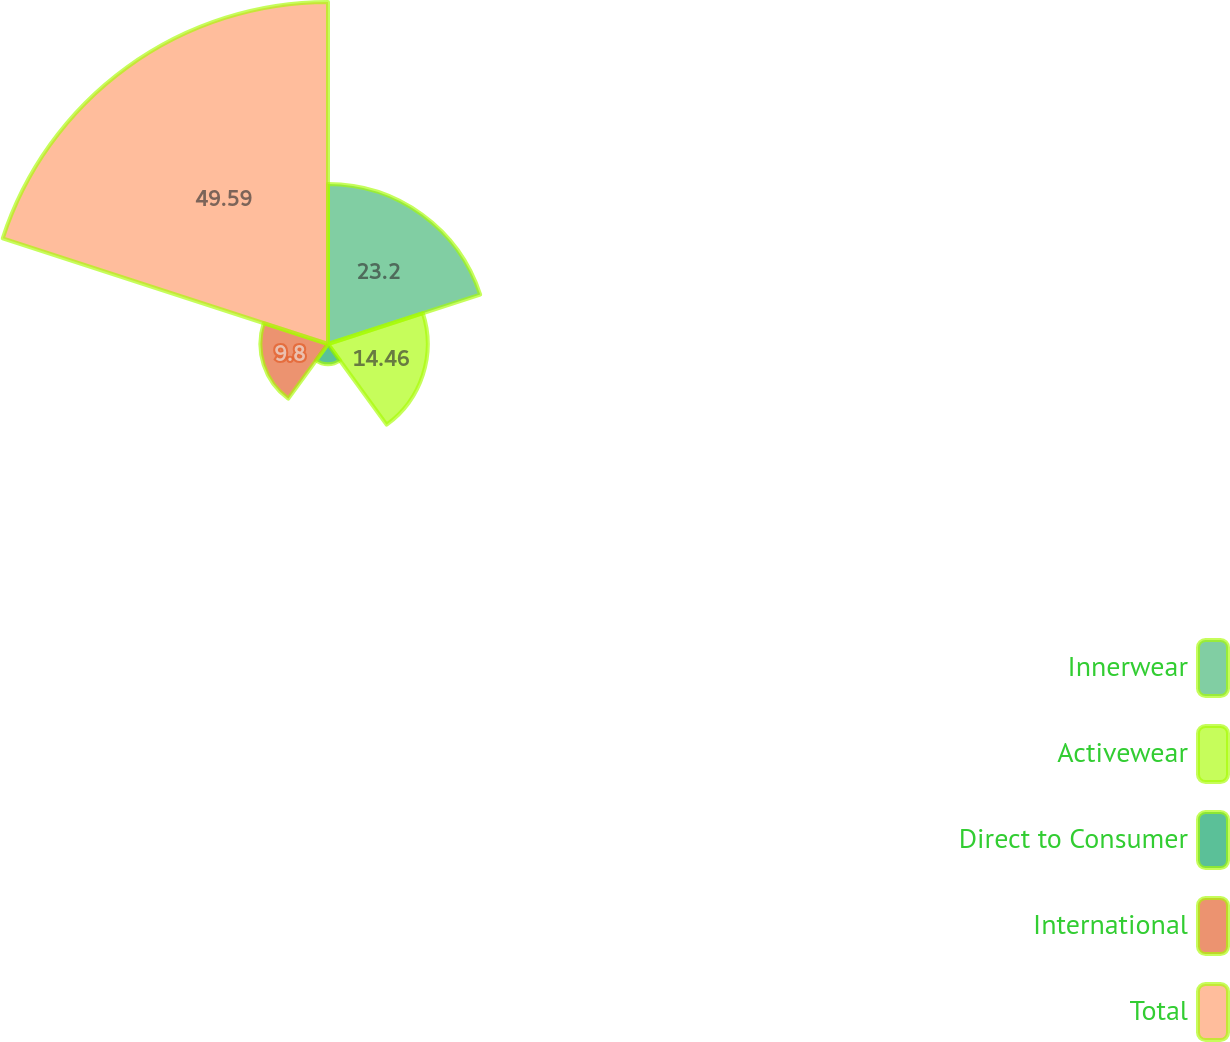<chart> <loc_0><loc_0><loc_500><loc_500><pie_chart><fcel>Innerwear<fcel>Activewear<fcel>Direct to Consumer<fcel>International<fcel>Total<nl><fcel>23.2%<fcel>14.46%<fcel>2.95%<fcel>9.8%<fcel>49.59%<nl></chart> 